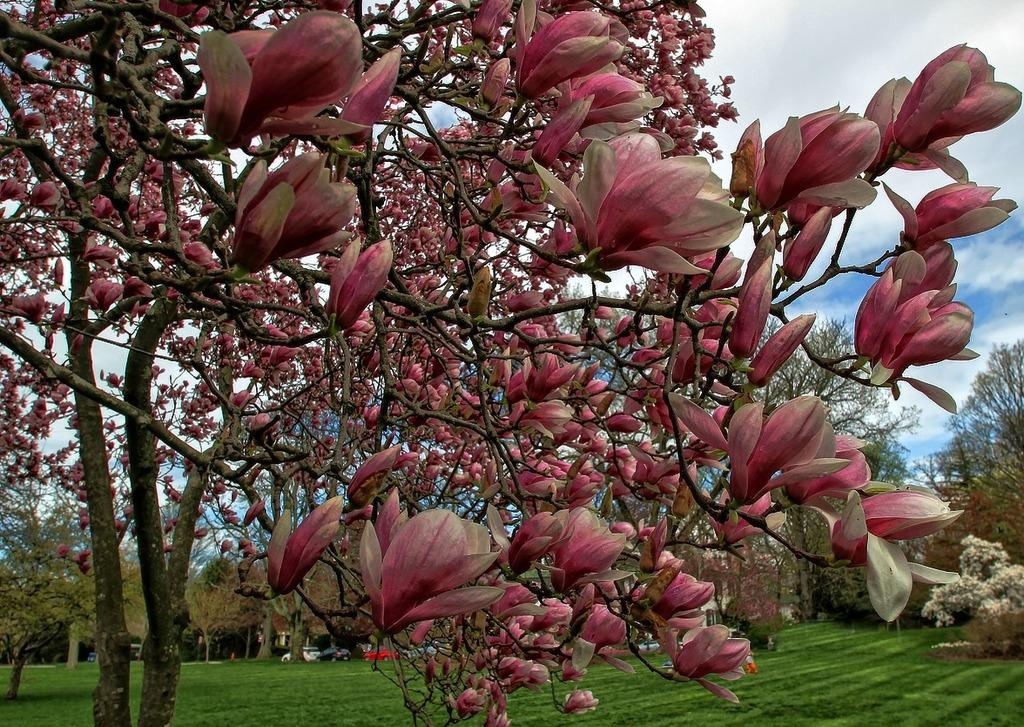What type of vegetation is present in the image? There are trees with flowers in the image. What else can be seen on the ground in the image? There is grass in the image. Are there any man-made objects visible in the image? Yes, there are cars in the image. What is visible in the background of the image? The sky is visible in the background of the image. What can be observed in the sky? There are clouds in the sky. How does the tree with flowers trick the cars in the image? There is no indication in the image that the tree with flowers is tricking the cars. Can you describe the attack made by the clouds in the image? There is no attack made by the clouds in the image; they are simply visible in the sky. 